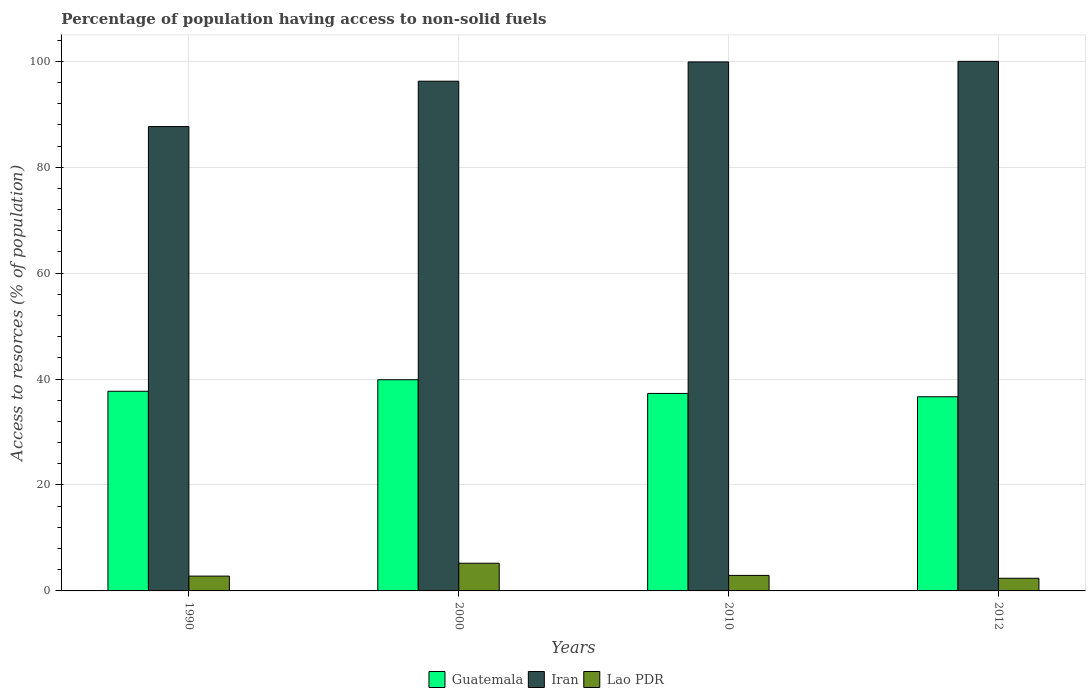Are the number of bars per tick equal to the number of legend labels?
Offer a very short reply. Yes. What is the percentage of population having access to non-solid fuels in Iran in 2000?
Offer a terse response. 96.24. Across all years, what is the maximum percentage of population having access to non-solid fuels in Guatemala?
Ensure brevity in your answer.  39.87. Across all years, what is the minimum percentage of population having access to non-solid fuels in Guatemala?
Ensure brevity in your answer.  36.66. In which year was the percentage of population having access to non-solid fuels in Lao PDR maximum?
Ensure brevity in your answer.  2000. In which year was the percentage of population having access to non-solid fuels in Iran minimum?
Keep it short and to the point. 1990. What is the total percentage of population having access to non-solid fuels in Iran in the graph?
Your answer should be compact. 383.78. What is the difference between the percentage of population having access to non-solid fuels in Guatemala in 2000 and that in 2010?
Your response must be concise. 2.58. What is the difference between the percentage of population having access to non-solid fuels in Lao PDR in 2012 and the percentage of population having access to non-solid fuels in Guatemala in 1990?
Provide a short and direct response. -35.31. What is the average percentage of population having access to non-solid fuels in Guatemala per year?
Offer a terse response. 37.88. In the year 1990, what is the difference between the percentage of population having access to non-solid fuels in Guatemala and percentage of population having access to non-solid fuels in Lao PDR?
Your answer should be very brief. 34.9. What is the ratio of the percentage of population having access to non-solid fuels in Iran in 1990 to that in 2010?
Give a very brief answer. 0.88. What is the difference between the highest and the second highest percentage of population having access to non-solid fuels in Iran?
Give a very brief answer. 0.11. What is the difference between the highest and the lowest percentage of population having access to non-solid fuels in Lao PDR?
Offer a terse response. 2.84. In how many years, is the percentage of population having access to non-solid fuels in Guatemala greater than the average percentage of population having access to non-solid fuels in Guatemala taken over all years?
Offer a very short reply. 1. What does the 1st bar from the left in 1990 represents?
Provide a short and direct response. Guatemala. What does the 3rd bar from the right in 2012 represents?
Ensure brevity in your answer.  Guatemala. What is the difference between two consecutive major ticks on the Y-axis?
Provide a succinct answer. 20. Are the values on the major ticks of Y-axis written in scientific E-notation?
Give a very brief answer. No. Does the graph contain grids?
Offer a terse response. Yes. How are the legend labels stacked?
Provide a succinct answer. Horizontal. What is the title of the graph?
Keep it short and to the point. Percentage of population having access to non-solid fuels. Does "Nicaragua" appear as one of the legend labels in the graph?
Provide a succinct answer. No. What is the label or title of the Y-axis?
Keep it short and to the point. Access to resorces (% of population). What is the Access to resorces (% of population) of Guatemala in 1990?
Keep it short and to the point. 37.7. What is the Access to resorces (% of population) of Iran in 1990?
Offer a terse response. 87.68. What is the Access to resorces (% of population) in Lao PDR in 1990?
Your answer should be very brief. 2.8. What is the Access to resorces (% of population) in Guatemala in 2000?
Give a very brief answer. 39.87. What is the Access to resorces (% of population) in Iran in 2000?
Your response must be concise. 96.24. What is the Access to resorces (% of population) in Lao PDR in 2000?
Provide a succinct answer. 5.23. What is the Access to resorces (% of population) of Guatemala in 2010?
Your response must be concise. 37.29. What is the Access to resorces (% of population) of Iran in 2010?
Provide a succinct answer. 99.88. What is the Access to resorces (% of population) of Lao PDR in 2010?
Your response must be concise. 2.93. What is the Access to resorces (% of population) in Guatemala in 2012?
Provide a succinct answer. 36.66. What is the Access to resorces (% of population) in Iran in 2012?
Your response must be concise. 99.99. What is the Access to resorces (% of population) in Lao PDR in 2012?
Offer a very short reply. 2.39. Across all years, what is the maximum Access to resorces (% of population) in Guatemala?
Offer a terse response. 39.87. Across all years, what is the maximum Access to resorces (% of population) of Iran?
Provide a succinct answer. 99.99. Across all years, what is the maximum Access to resorces (% of population) in Lao PDR?
Your answer should be very brief. 5.23. Across all years, what is the minimum Access to resorces (% of population) of Guatemala?
Provide a short and direct response. 36.66. Across all years, what is the minimum Access to resorces (% of population) in Iran?
Make the answer very short. 87.68. Across all years, what is the minimum Access to resorces (% of population) of Lao PDR?
Your answer should be compact. 2.39. What is the total Access to resorces (% of population) in Guatemala in the graph?
Give a very brief answer. 151.52. What is the total Access to resorces (% of population) in Iran in the graph?
Your response must be concise. 383.78. What is the total Access to resorces (% of population) of Lao PDR in the graph?
Provide a succinct answer. 13.35. What is the difference between the Access to resorces (% of population) in Guatemala in 1990 and that in 2000?
Your answer should be compact. -2.17. What is the difference between the Access to resorces (% of population) of Iran in 1990 and that in 2000?
Make the answer very short. -8.57. What is the difference between the Access to resorces (% of population) of Lao PDR in 1990 and that in 2000?
Ensure brevity in your answer.  -2.43. What is the difference between the Access to resorces (% of population) in Guatemala in 1990 and that in 2010?
Offer a terse response. 0.41. What is the difference between the Access to resorces (% of population) of Iran in 1990 and that in 2010?
Give a very brief answer. -12.2. What is the difference between the Access to resorces (% of population) of Lao PDR in 1990 and that in 2010?
Your answer should be compact. -0.14. What is the difference between the Access to resorces (% of population) of Guatemala in 1990 and that in 2012?
Your answer should be compact. 1.04. What is the difference between the Access to resorces (% of population) of Iran in 1990 and that in 2012?
Provide a short and direct response. -12.31. What is the difference between the Access to resorces (% of population) in Lao PDR in 1990 and that in 2012?
Ensure brevity in your answer.  0.41. What is the difference between the Access to resorces (% of population) in Guatemala in 2000 and that in 2010?
Your response must be concise. 2.58. What is the difference between the Access to resorces (% of population) in Iran in 2000 and that in 2010?
Your answer should be compact. -3.64. What is the difference between the Access to resorces (% of population) in Lao PDR in 2000 and that in 2010?
Offer a terse response. 2.3. What is the difference between the Access to resorces (% of population) in Guatemala in 2000 and that in 2012?
Give a very brief answer. 3.21. What is the difference between the Access to resorces (% of population) in Iran in 2000 and that in 2012?
Your answer should be very brief. -3.75. What is the difference between the Access to resorces (% of population) in Lao PDR in 2000 and that in 2012?
Your answer should be very brief. 2.84. What is the difference between the Access to resorces (% of population) in Guatemala in 2010 and that in 2012?
Offer a very short reply. 0.63. What is the difference between the Access to resorces (% of population) of Iran in 2010 and that in 2012?
Provide a short and direct response. -0.11. What is the difference between the Access to resorces (% of population) of Lao PDR in 2010 and that in 2012?
Your answer should be very brief. 0.54. What is the difference between the Access to resorces (% of population) of Guatemala in 1990 and the Access to resorces (% of population) of Iran in 2000?
Ensure brevity in your answer.  -58.54. What is the difference between the Access to resorces (% of population) in Guatemala in 1990 and the Access to resorces (% of population) in Lao PDR in 2000?
Keep it short and to the point. 32.47. What is the difference between the Access to resorces (% of population) in Iran in 1990 and the Access to resorces (% of population) in Lao PDR in 2000?
Give a very brief answer. 82.45. What is the difference between the Access to resorces (% of population) in Guatemala in 1990 and the Access to resorces (% of population) in Iran in 2010?
Your answer should be very brief. -62.18. What is the difference between the Access to resorces (% of population) of Guatemala in 1990 and the Access to resorces (% of population) of Lao PDR in 2010?
Give a very brief answer. 34.77. What is the difference between the Access to resorces (% of population) of Iran in 1990 and the Access to resorces (% of population) of Lao PDR in 2010?
Give a very brief answer. 84.74. What is the difference between the Access to resorces (% of population) in Guatemala in 1990 and the Access to resorces (% of population) in Iran in 2012?
Your answer should be very brief. -62.29. What is the difference between the Access to resorces (% of population) in Guatemala in 1990 and the Access to resorces (% of population) in Lao PDR in 2012?
Offer a very short reply. 35.31. What is the difference between the Access to resorces (% of population) of Iran in 1990 and the Access to resorces (% of population) of Lao PDR in 2012?
Provide a short and direct response. 85.29. What is the difference between the Access to resorces (% of population) of Guatemala in 2000 and the Access to resorces (% of population) of Iran in 2010?
Give a very brief answer. -60.01. What is the difference between the Access to resorces (% of population) of Guatemala in 2000 and the Access to resorces (% of population) of Lao PDR in 2010?
Give a very brief answer. 36.94. What is the difference between the Access to resorces (% of population) of Iran in 2000 and the Access to resorces (% of population) of Lao PDR in 2010?
Offer a terse response. 93.31. What is the difference between the Access to resorces (% of population) of Guatemala in 2000 and the Access to resorces (% of population) of Iran in 2012?
Provide a short and direct response. -60.12. What is the difference between the Access to resorces (% of population) of Guatemala in 2000 and the Access to resorces (% of population) of Lao PDR in 2012?
Provide a succinct answer. 37.48. What is the difference between the Access to resorces (% of population) of Iran in 2000 and the Access to resorces (% of population) of Lao PDR in 2012?
Keep it short and to the point. 93.85. What is the difference between the Access to resorces (% of population) in Guatemala in 2010 and the Access to resorces (% of population) in Iran in 2012?
Give a very brief answer. -62.7. What is the difference between the Access to resorces (% of population) in Guatemala in 2010 and the Access to resorces (% of population) in Lao PDR in 2012?
Offer a terse response. 34.9. What is the difference between the Access to resorces (% of population) of Iran in 2010 and the Access to resorces (% of population) of Lao PDR in 2012?
Your answer should be compact. 97.49. What is the average Access to resorces (% of population) of Guatemala per year?
Make the answer very short. 37.88. What is the average Access to resorces (% of population) of Iran per year?
Provide a short and direct response. 95.95. What is the average Access to resorces (% of population) of Lao PDR per year?
Your answer should be very brief. 3.34. In the year 1990, what is the difference between the Access to resorces (% of population) in Guatemala and Access to resorces (% of population) in Iran?
Your answer should be compact. -49.98. In the year 1990, what is the difference between the Access to resorces (% of population) in Guatemala and Access to resorces (% of population) in Lao PDR?
Provide a short and direct response. 34.9. In the year 1990, what is the difference between the Access to resorces (% of population) of Iran and Access to resorces (% of population) of Lao PDR?
Offer a terse response. 84.88. In the year 2000, what is the difference between the Access to resorces (% of population) in Guatemala and Access to resorces (% of population) in Iran?
Give a very brief answer. -56.37. In the year 2000, what is the difference between the Access to resorces (% of population) of Guatemala and Access to resorces (% of population) of Lao PDR?
Your response must be concise. 34.64. In the year 2000, what is the difference between the Access to resorces (% of population) of Iran and Access to resorces (% of population) of Lao PDR?
Offer a terse response. 91.01. In the year 2010, what is the difference between the Access to resorces (% of population) of Guatemala and Access to resorces (% of population) of Iran?
Make the answer very short. -62.59. In the year 2010, what is the difference between the Access to resorces (% of population) of Guatemala and Access to resorces (% of population) of Lao PDR?
Offer a terse response. 34.36. In the year 2010, what is the difference between the Access to resorces (% of population) in Iran and Access to resorces (% of population) in Lao PDR?
Offer a very short reply. 96.95. In the year 2012, what is the difference between the Access to resorces (% of population) of Guatemala and Access to resorces (% of population) of Iran?
Make the answer very short. -63.33. In the year 2012, what is the difference between the Access to resorces (% of population) in Guatemala and Access to resorces (% of population) in Lao PDR?
Ensure brevity in your answer.  34.27. In the year 2012, what is the difference between the Access to resorces (% of population) in Iran and Access to resorces (% of population) in Lao PDR?
Ensure brevity in your answer.  97.6. What is the ratio of the Access to resorces (% of population) in Guatemala in 1990 to that in 2000?
Make the answer very short. 0.95. What is the ratio of the Access to resorces (% of population) in Iran in 1990 to that in 2000?
Give a very brief answer. 0.91. What is the ratio of the Access to resorces (% of population) of Lao PDR in 1990 to that in 2000?
Offer a terse response. 0.54. What is the ratio of the Access to resorces (% of population) of Guatemala in 1990 to that in 2010?
Your answer should be compact. 1.01. What is the ratio of the Access to resorces (% of population) in Iran in 1990 to that in 2010?
Give a very brief answer. 0.88. What is the ratio of the Access to resorces (% of population) of Lao PDR in 1990 to that in 2010?
Provide a short and direct response. 0.95. What is the ratio of the Access to resorces (% of population) of Guatemala in 1990 to that in 2012?
Make the answer very short. 1.03. What is the ratio of the Access to resorces (% of population) in Iran in 1990 to that in 2012?
Your answer should be compact. 0.88. What is the ratio of the Access to resorces (% of population) in Lao PDR in 1990 to that in 2012?
Provide a succinct answer. 1.17. What is the ratio of the Access to resorces (% of population) of Guatemala in 2000 to that in 2010?
Make the answer very short. 1.07. What is the ratio of the Access to resorces (% of population) in Iran in 2000 to that in 2010?
Your answer should be very brief. 0.96. What is the ratio of the Access to resorces (% of population) of Lao PDR in 2000 to that in 2010?
Offer a very short reply. 1.78. What is the ratio of the Access to resorces (% of population) in Guatemala in 2000 to that in 2012?
Ensure brevity in your answer.  1.09. What is the ratio of the Access to resorces (% of population) in Iran in 2000 to that in 2012?
Provide a succinct answer. 0.96. What is the ratio of the Access to resorces (% of population) in Lao PDR in 2000 to that in 2012?
Your answer should be compact. 2.19. What is the ratio of the Access to resorces (% of population) of Guatemala in 2010 to that in 2012?
Provide a short and direct response. 1.02. What is the ratio of the Access to resorces (% of population) in Iran in 2010 to that in 2012?
Provide a succinct answer. 1. What is the ratio of the Access to resorces (% of population) in Lao PDR in 2010 to that in 2012?
Ensure brevity in your answer.  1.23. What is the difference between the highest and the second highest Access to resorces (% of population) in Guatemala?
Your response must be concise. 2.17. What is the difference between the highest and the second highest Access to resorces (% of population) of Iran?
Offer a terse response. 0.11. What is the difference between the highest and the second highest Access to resorces (% of population) of Lao PDR?
Offer a terse response. 2.3. What is the difference between the highest and the lowest Access to resorces (% of population) of Guatemala?
Give a very brief answer. 3.21. What is the difference between the highest and the lowest Access to resorces (% of population) in Iran?
Provide a short and direct response. 12.31. What is the difference between the highest and the lowest Access to resorces (% of population) in Lao PDR?
Offer a very short reply. 2.84. 